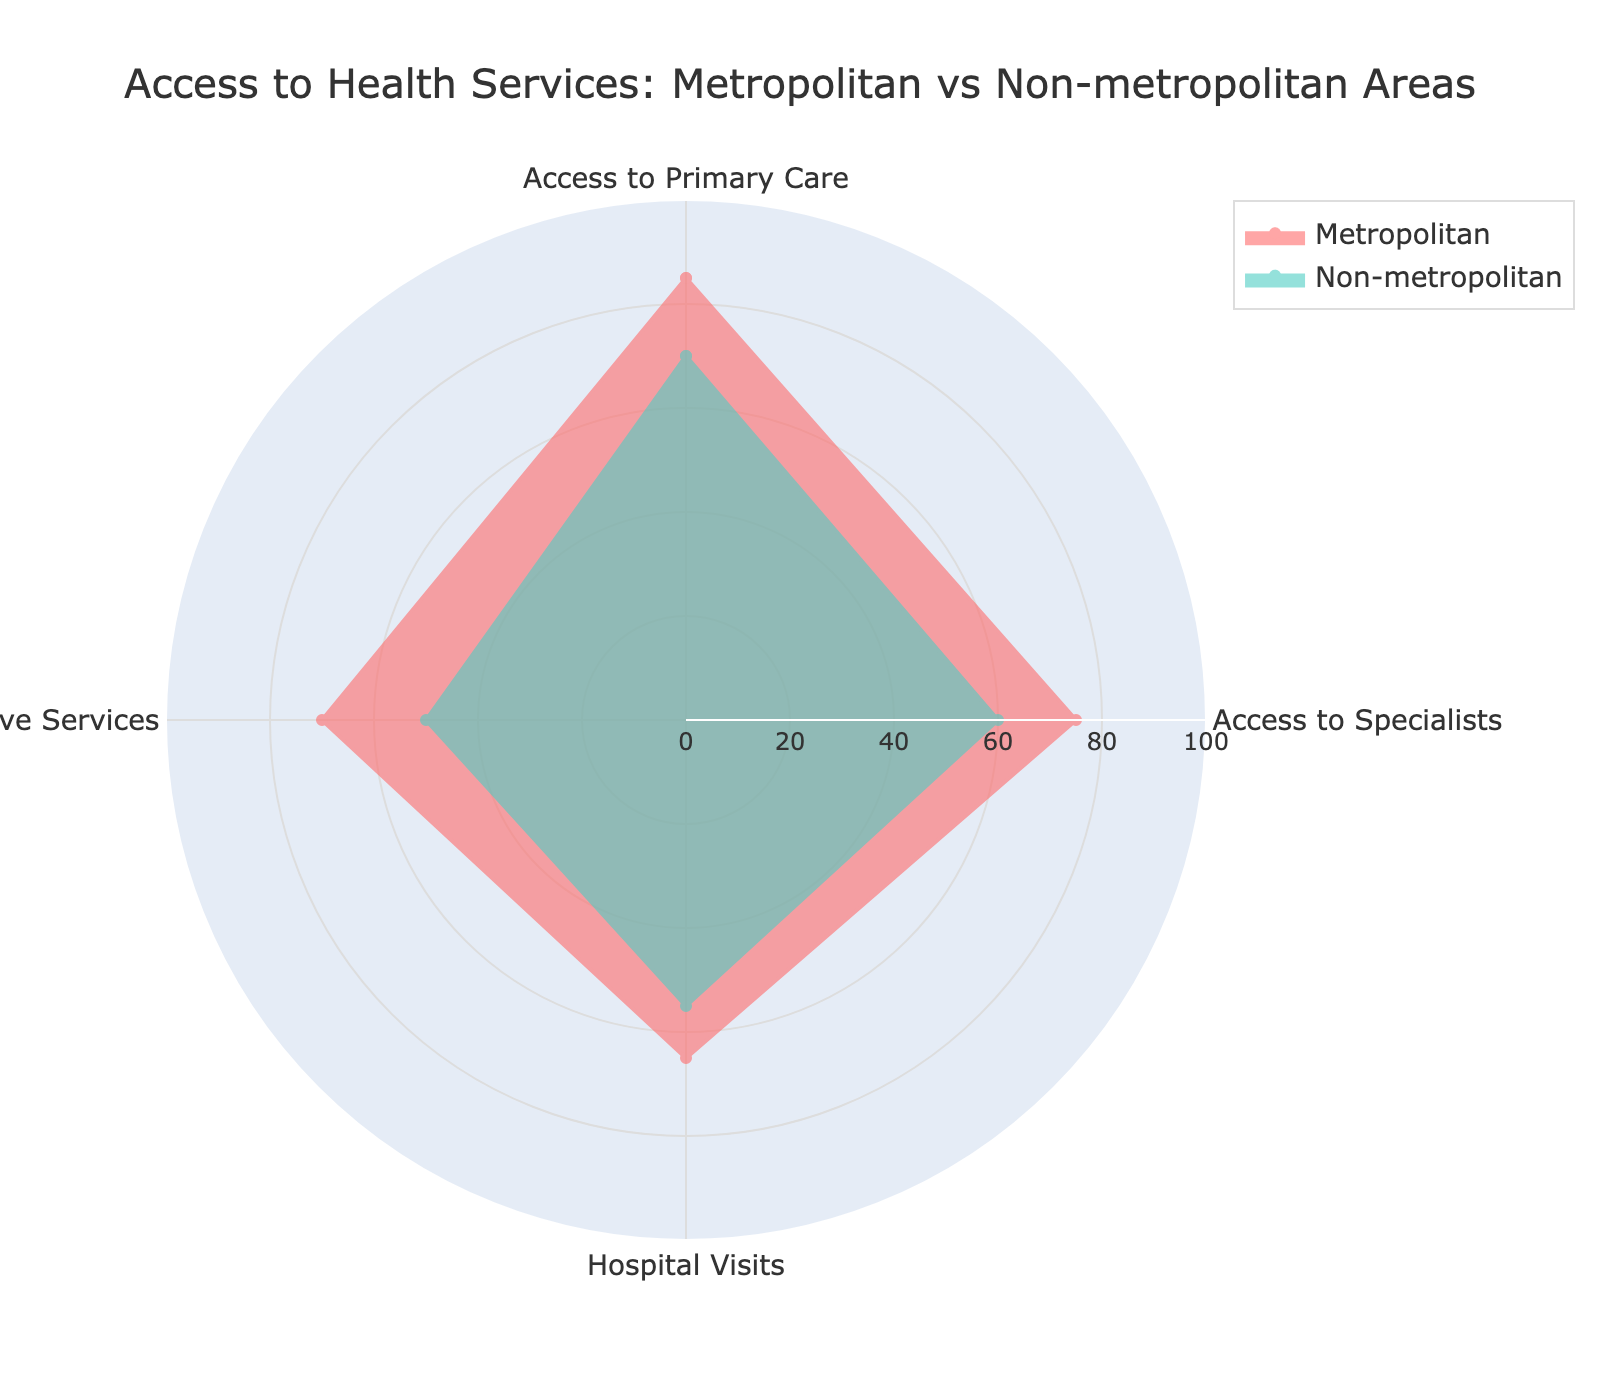What is the title of the radar chart? The title can be found at the top of the radar chart.
Answer: Access to Health Services: Metropolitan vs Non-metropolitan Areas Which area has the highest access to primary care? By comparing the values for 'Access to Primary Care' between Metropolitan and Non-metropolitan areas, the Metropolitan area has a higher value.
Answer: Metropolitan What is the difference in hospital visits between metropolitan and non-metropolitan areas? 'Hospital Visits' for Metropolitan is 65 and for Non-metropolitan is 55. The difference is 65 - 55.
Answer: 10 Which category has the largest discrepancy between metropolitan and non-metropolitan areas? By comparing all categories, 'Access to Specialists' has the largest difference (75 in Metropolitan and 60 in Non-metropolitan).
Answer: Access to Specialists What is the average access to health services value for non-metropolitan areas across all categories? Sum the values for non-metropolitan areas (70 + 60 + 55 + 50) and divide by the number of categories (4).
Answer: 58.75 In which category does the non-metropolitan area perform worst? The smallest value among 'Access to Primary Care', 'Access to Specialists', 'Hospital Visits', and 'Preventive Services' for Non-metropolitan areas is the worst.
Answer: Preventive Services Compare the values of preventive services in both areas. Which one is higher? 'Preventive Services' is 70 in Metropolitan and 50 in Non-metropolitan. The Metropolitan area is higher.
Answer: Metropolitan How many categories are compared in this radar chart? The radar chart contains four categories: 'Access to Primary Care', 'Access to Specialists', 'Hospital Visits', and 'Preventive Services'.
Answer: Four What is the average difference between metropolitan and non-metropolitan areas across all categories? Compute the differences: (85-70) + (75-60) + (65-55) + (70-50), which gives 60. Divide 60 by 4 (number of categories).
Answer: 15 